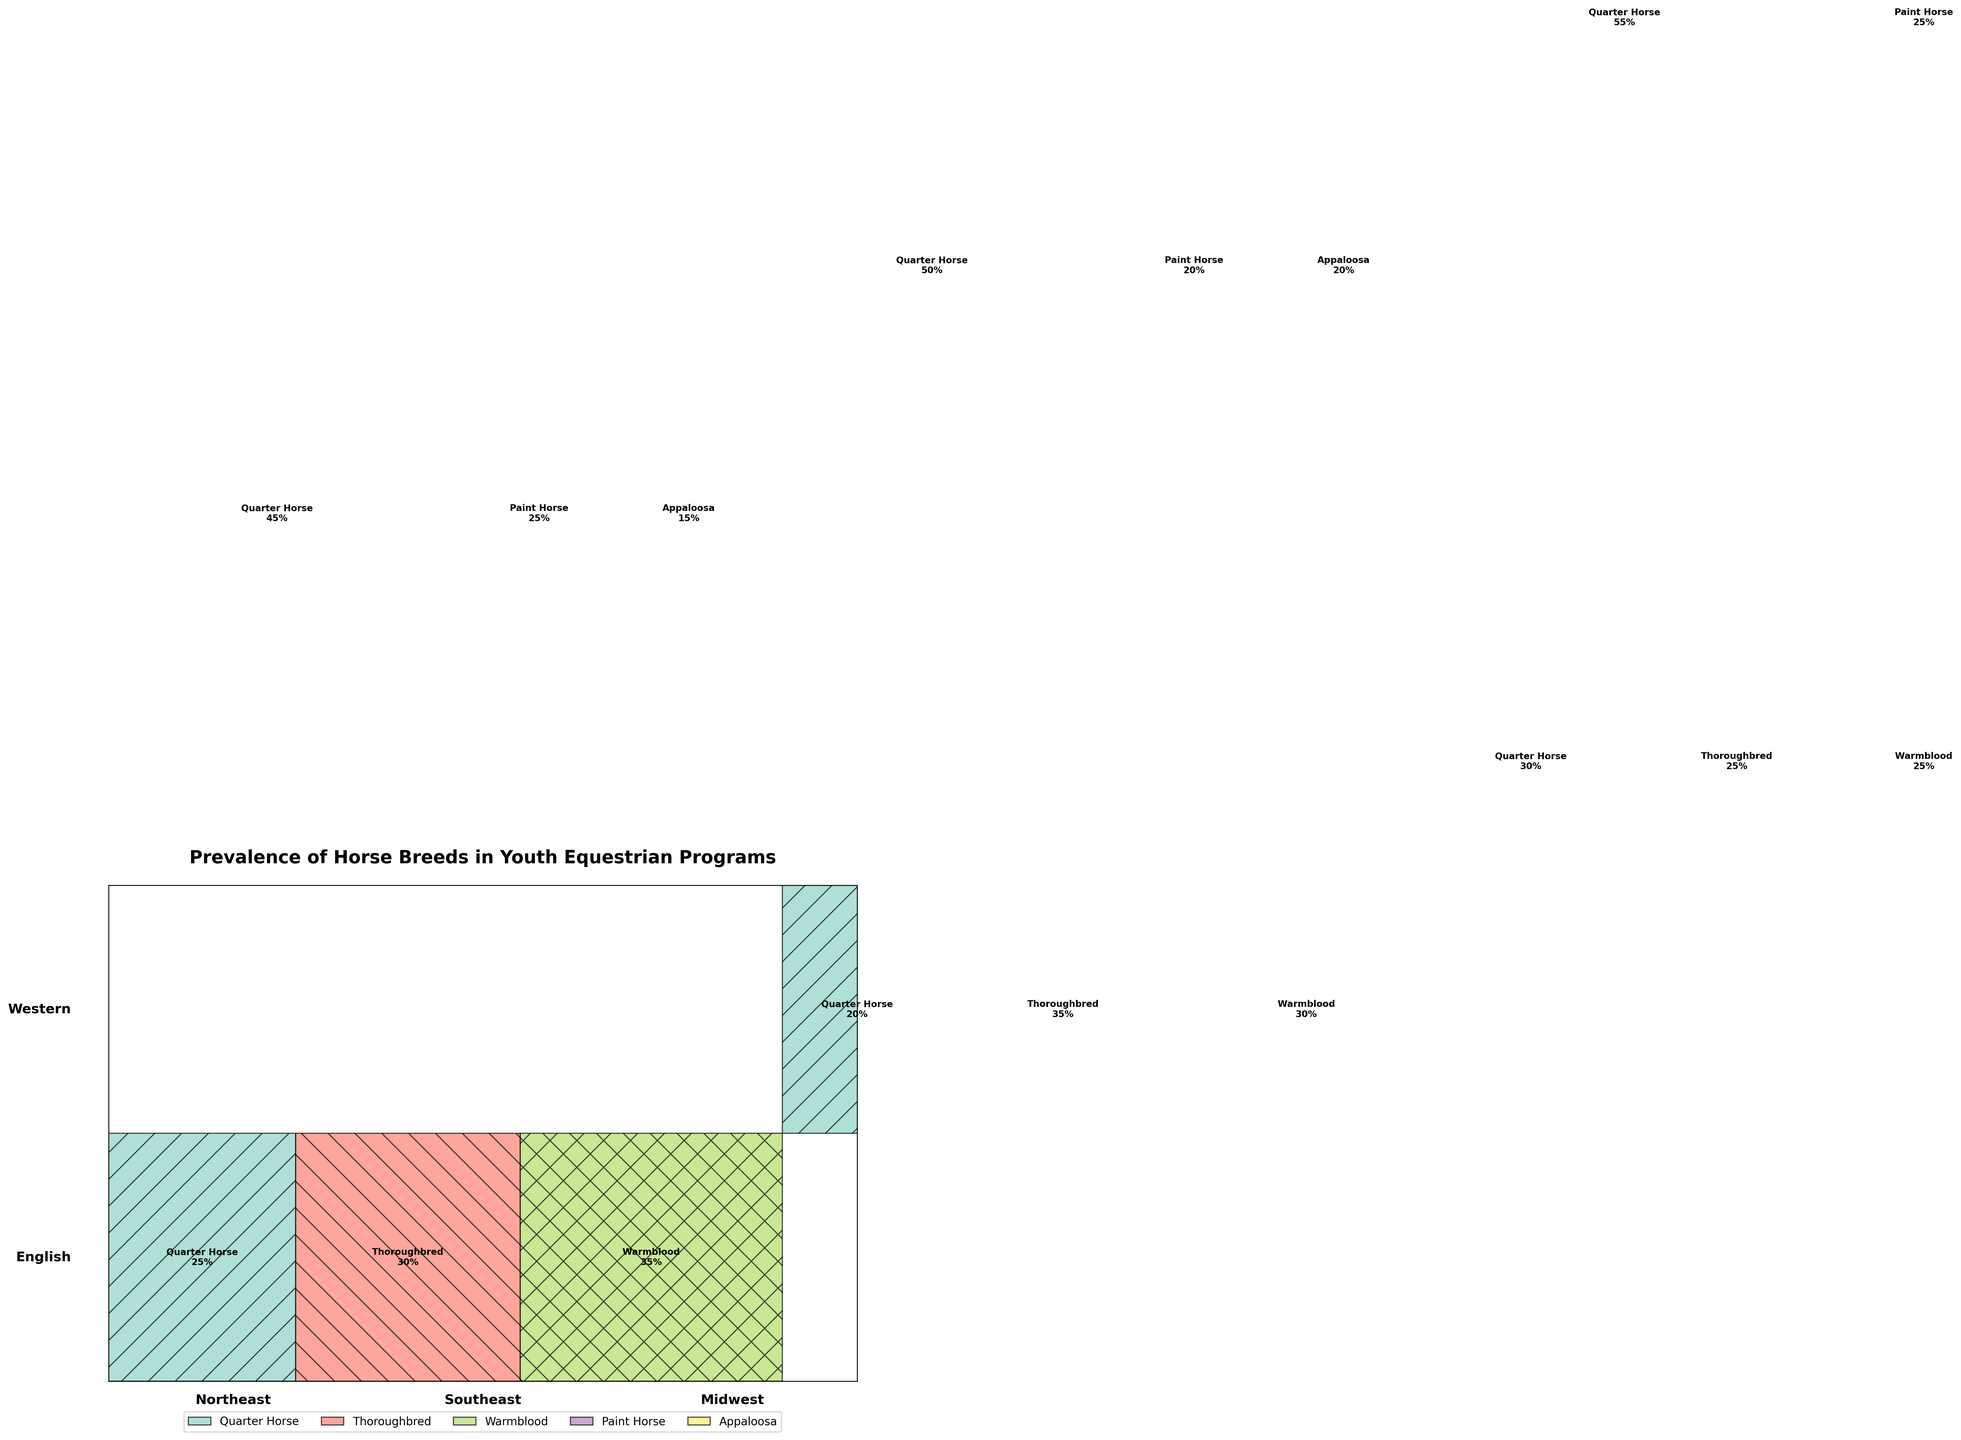What titles distinguish the different ride disciplines in the plot? The different riding disciplines are labeled on the left-hand side of the mosaic plot. By referring to these labels, one can identify the distinct disciplines depicted in the figure.
Answer: English, Western Which breed is most prevalent in the English discipline in the Northeast region? In the English discipline for the Northeast region, the Warmblood breed occupies the largest portion of the mosaic plot, indicating its highest prevalence in this category.
Answer: Warmblood Compare the prevalence of Quarter Horses and Thoroughbreds in the Southeast region for the English discipline. Examining the English discipline in the Southeast region, the mosaic plot shows that Thoroughbreds have a higher percentage (35%) compared to Quarter Horses (20%).
Answer: Thoroughbreds are more prevalent How does the prevalence of Appaloosas differ between the Western disciplines in the Northeast and Midwest regions? The prevalence of Appaloosas in the Western discipline is represented by the width of sections in the mosaic plot. Appaloosas have a 15% prevalence in the Northeast and a 10% prevalence in the Midwest, meaning they are more common in the Northeast.
Answer: More prevalent in the Northeast What is the overall trend for the Quarter Horse breed across all categories? When reviewing Quarter Horse percentages across all disciplines and regions, it's noticeable that they consistently have high percentages, particularly in the Western discipline, with percentages like 45%, 50%, and 55%. This indicates Quarter Horses are dominant across most categories.
Answer: Dominant across most categories Determine the breed with the lowest overall presence in the Western discipline. By observing the sections in the Western discipline, the Appaloosa breed has the smallest cumulative area across the three regions (Northeast, Southeast, Midwest), making it the breed with the lowest overall presence.
Answer: Appaloosa What is the combined prevalence of Thoroughbreds in the English discipline across all regions? Adding the percentages of Thoroughbreds in the English discipline for Northeast (30%), Southeast (35%), and Midwest (25%) provides their combined prevalence: 30% + 35% + 25% = 90%.
Answer: 90% Which region has the highest prevalence of Warmbloods in the English discipline? Viewing the mosaic plot segments for Warmbloods in the English discipline, they have the highest prevalence in the Northeast region with 35%.
Answer: Northeast How does the paint horse's prevalence in the Southeast region for the Western discipline compare to its prevalence in the Northeast? In the Western discipline, the mosaic plot shows Paint Horses with a prevalence of 20% in the Southeast and 25% in the Northeast, meaning they are more common in the Northeast.
Answer: More common in the Northeast What insight does the mosaic plot give about the diversity of horse breeds within the Western discipline in the Midwest region? In the Western discipline in the Midwest region, Quarter Horses dominate with 55%, while Paint Horses and Appaloosas are less represented with 25% and 10%, respectively. This indicates a lower diversity of breeds, with a heavy preference towards Quarter Horses.
Answer: Lower diversity, dominated by Quarter Horses 